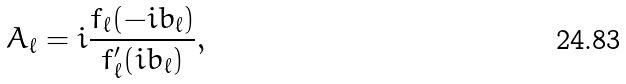Convert formula to latex. <formula><loc_0><loc_0><loc_500><loc_500>A _ { \ell } = i \frac { f _ { \ell } ( - i b _ { \ell } ) } { f ^ { \prime } _ { \ell } ( i b _ { \ell } ) } ,</formula> 